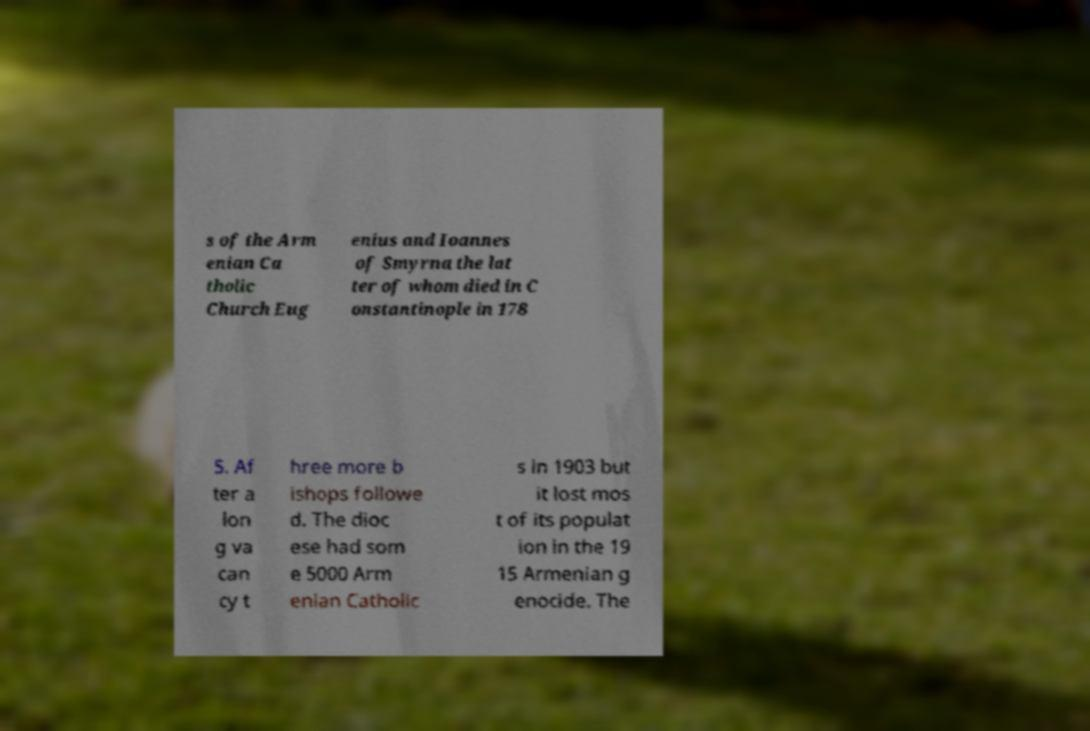What messages or text are displayed in this image? I need them in a readable, typed format. s of the Arm enian Ca tholic Church Eug enius and Ioannes of Smyrna the lat ter of whom died in C onstantinople in 178 5. Af ter a lon g va can cy t hree more b ishops followe d. The dioc ese had som e 5000 Arm enian Catholic s in 1903 but it lost mos t of its populat ion in the 19 15 Armenian g enocide. The 